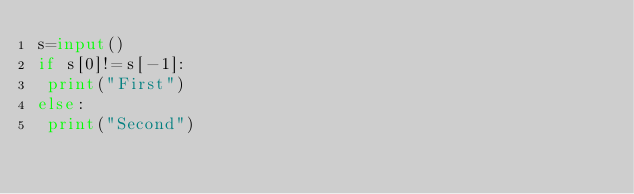<code> <loc_0><loc_0><loc_500><loc_500><_Python_>s=input()
if s[0]!=s[-1]:
 print("First")
else:
 print("Second")</code> 